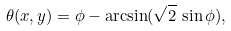Convert formula to latex. <formula><loc_0><loc_0><loc_500><loc_500>\theta ( x , y ) = \phi - \arcsin ( \sqrt { 2 } \, \sin \phi ) ,</formula> 